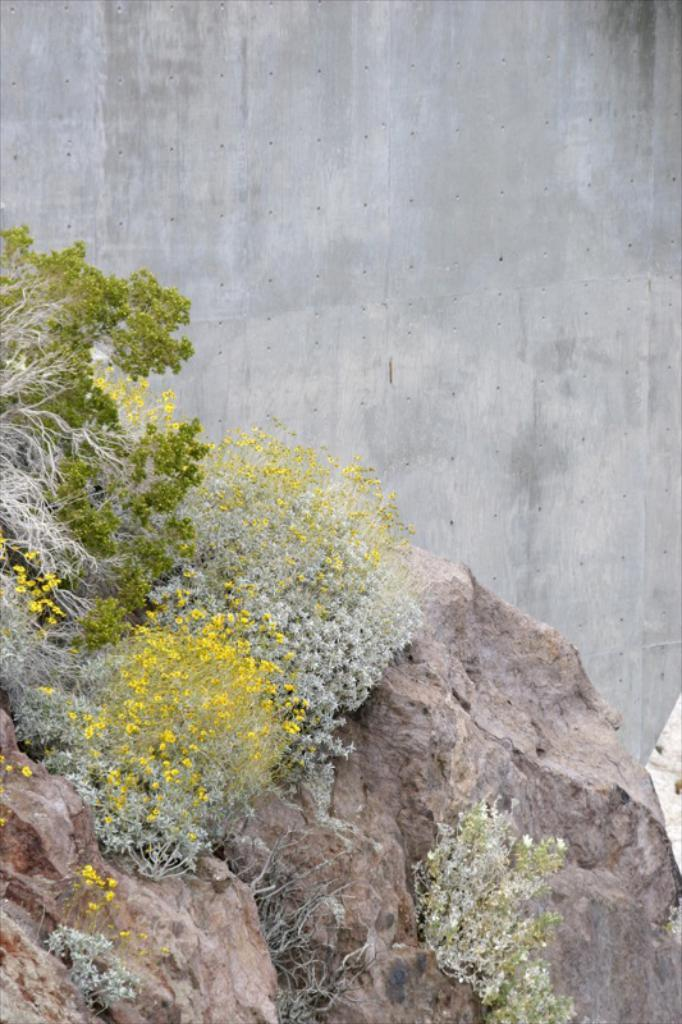What is the main subject in the center of the image? There is a rock in the center of the image. What is growing on the rock? There are bushes on the rock. What can be seen in the background of the image? There is a wall in the background of the image. What type of toy can be seen playing with prose in the image? There is no toy or prose present in the image; it features a rock with bushes and a wall in the background. 